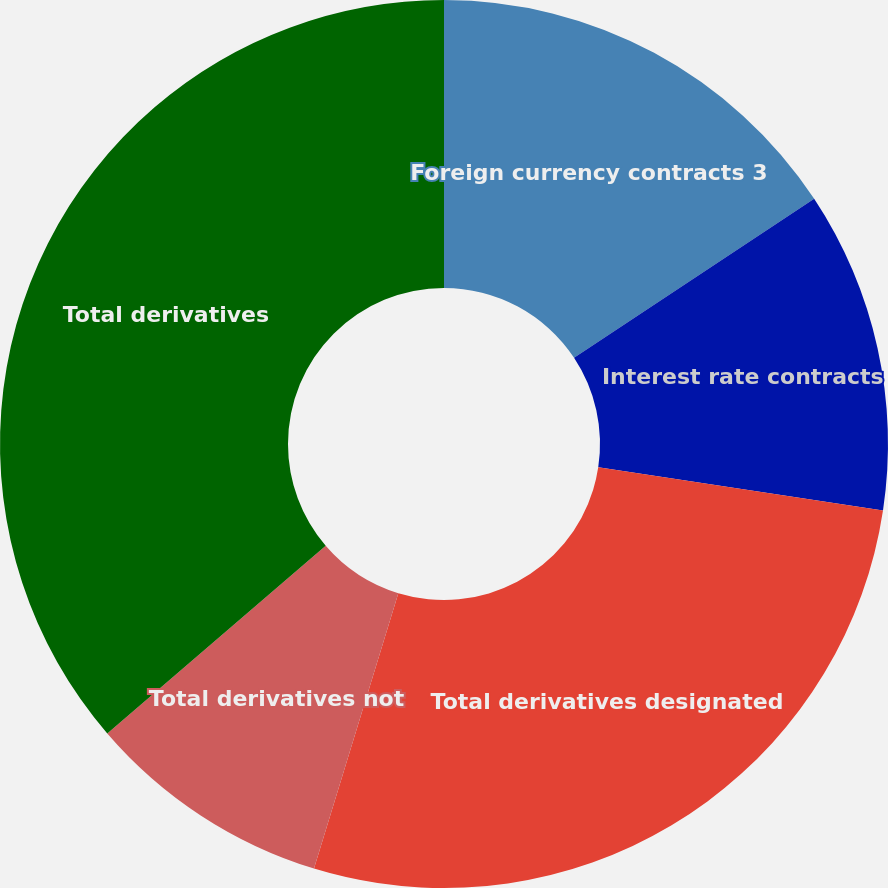Convert chart. <chart><loc_0><loc_0><loc_500><loc_500><pie_chart><fcel>Foreign currency contracts 3<fcel>Interest rate contracts<fcel>Total derivatives designated<fcel>Total derivatives not<fcel>Total derivatives<nl><fcel>15.69%<fcel>11.7%<fcel>27.34%<fcel>8.97%<fcel>36.3%<nl></chart> 